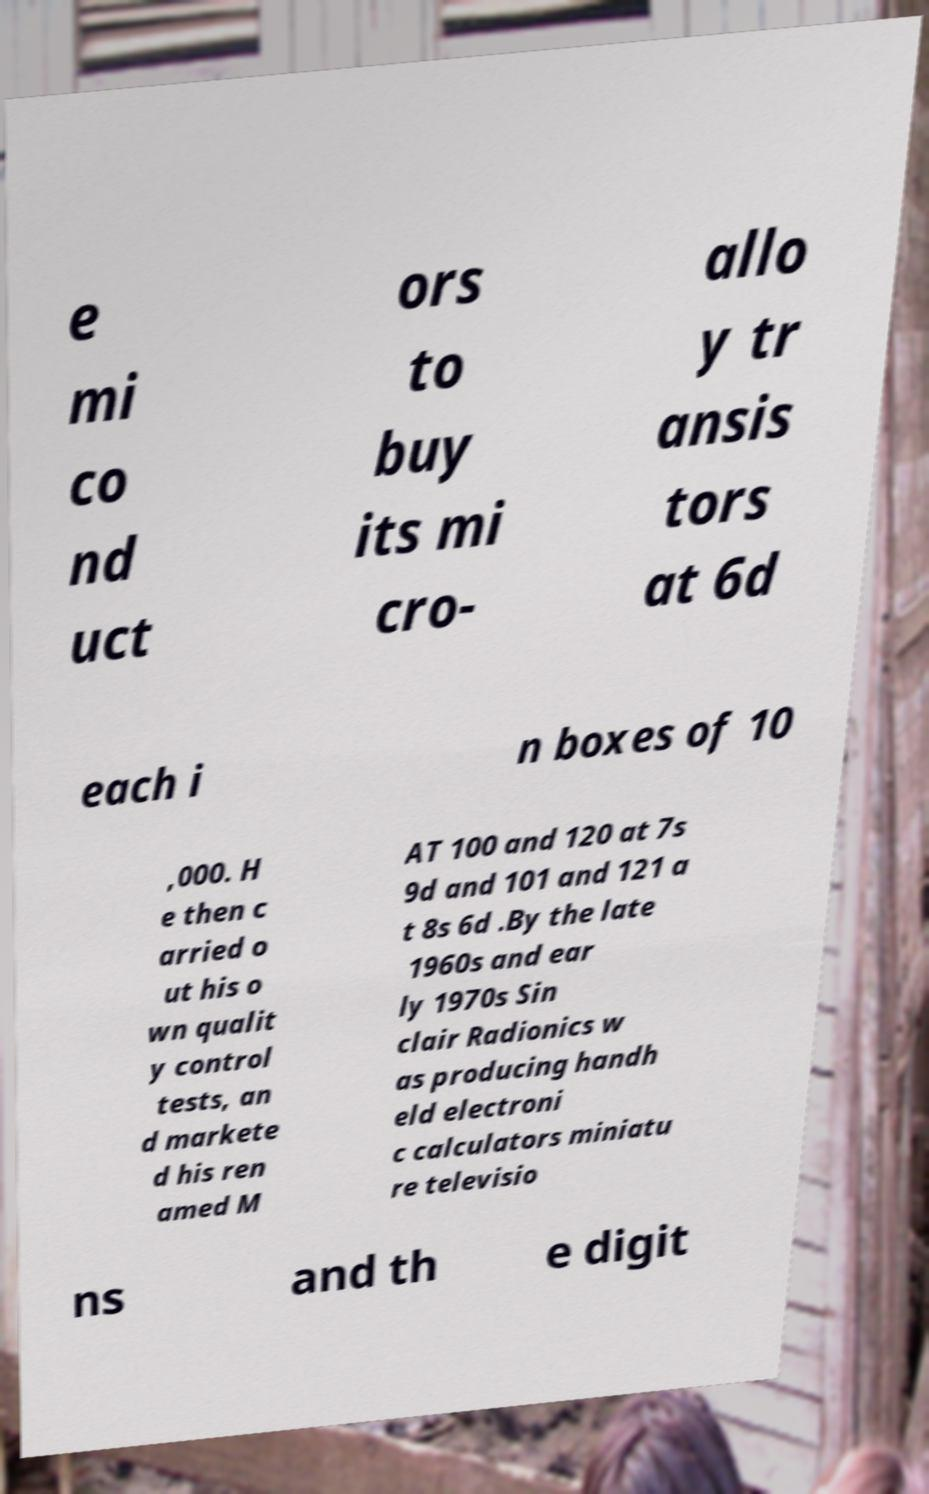There's text embedded in this image that I need extracted. Can you transcribe it verbatim? e mi co nd uct ors to buy its mi cro- allo y tr ansis tors at 6d each i n boxes of 10 ,000. H e then c arried o ut his o wn qualit y control tests, an d markete d his ren amed M AT 100 and 120 at 7s 9d and 101 and 121 a t 8s 6d .By the late 1960s and ear ly 1970s Sin clair Radionics w as producing handh eld electroni c calculators miniatu re televisio ns and th e digit 